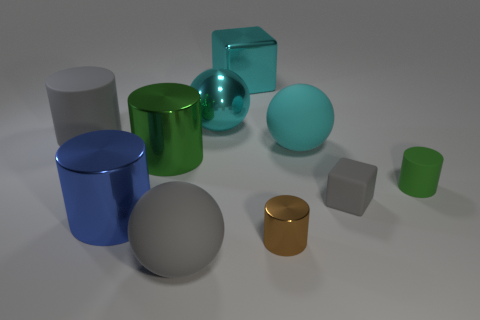Are any large red cylinders visible?
Offer a very short reply. No. There is a brown cylinder that is the same material as the blue object; what size is it?
Provide a succinct answer. Small. Is there a block of the same color as the tiny matte cylinder?
Give a very brief answer. No. Does the rubber cylinder that is to the left of the large cube have the same color as the block to the left of the small gray cube?
Offer a terse response. No. What is the size of the rubber cylinder that is the same color as the small block?
Your answer should be compact. Large. Is there a green sphere that has the same material as the small gray block?
Keep it short and to the point. No. What color is the tiny shiny cylinder?
Offer a very short reply. Brown. There is a cyan ball behind the gray matte object on the left side of the big gray thing that is on the right side of the big gray rubber cylinder; what is its size?
Your answer should be very brief. Large. What number of other things are there of the same shape as the large blue thing?
Offer a very short reply. 4. There is a sphere that is both to the left of the tiny brown thing and behind the blue metal object; what color is it?
Keep it short and to the point. Cyan. 